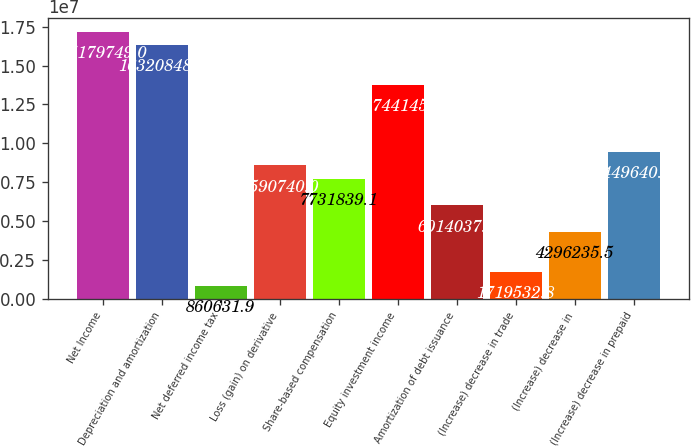Convert chart to OTSL. <chart><loc_0><loc_0><loc_500><loc_500><bar_chart><fcel>Net Income<fcel>Depreciation and amortization<fcel>Net deferred income tax<fcel>Loss (gain) on derivative<fcel>Share-based compensation<fcel>Equity investment income<fcel>Amortization of debt issuance<fcel>(Increase) decrease in trade<fcel>(Increase) decrease in<fcel>(Increase) decrease in prepaid<nl><fcel>1.71797e+07<fcel>1.63208e+07<fcel>860632<fcel>8.59074e+06<fcel>7.73184e+06<fcel>1.37441e+07<fcel>6.01404e+06<fcel>1.71953e+06<fcel>4.29624e+06<fcel>9.44964e+06<nl></chart> 